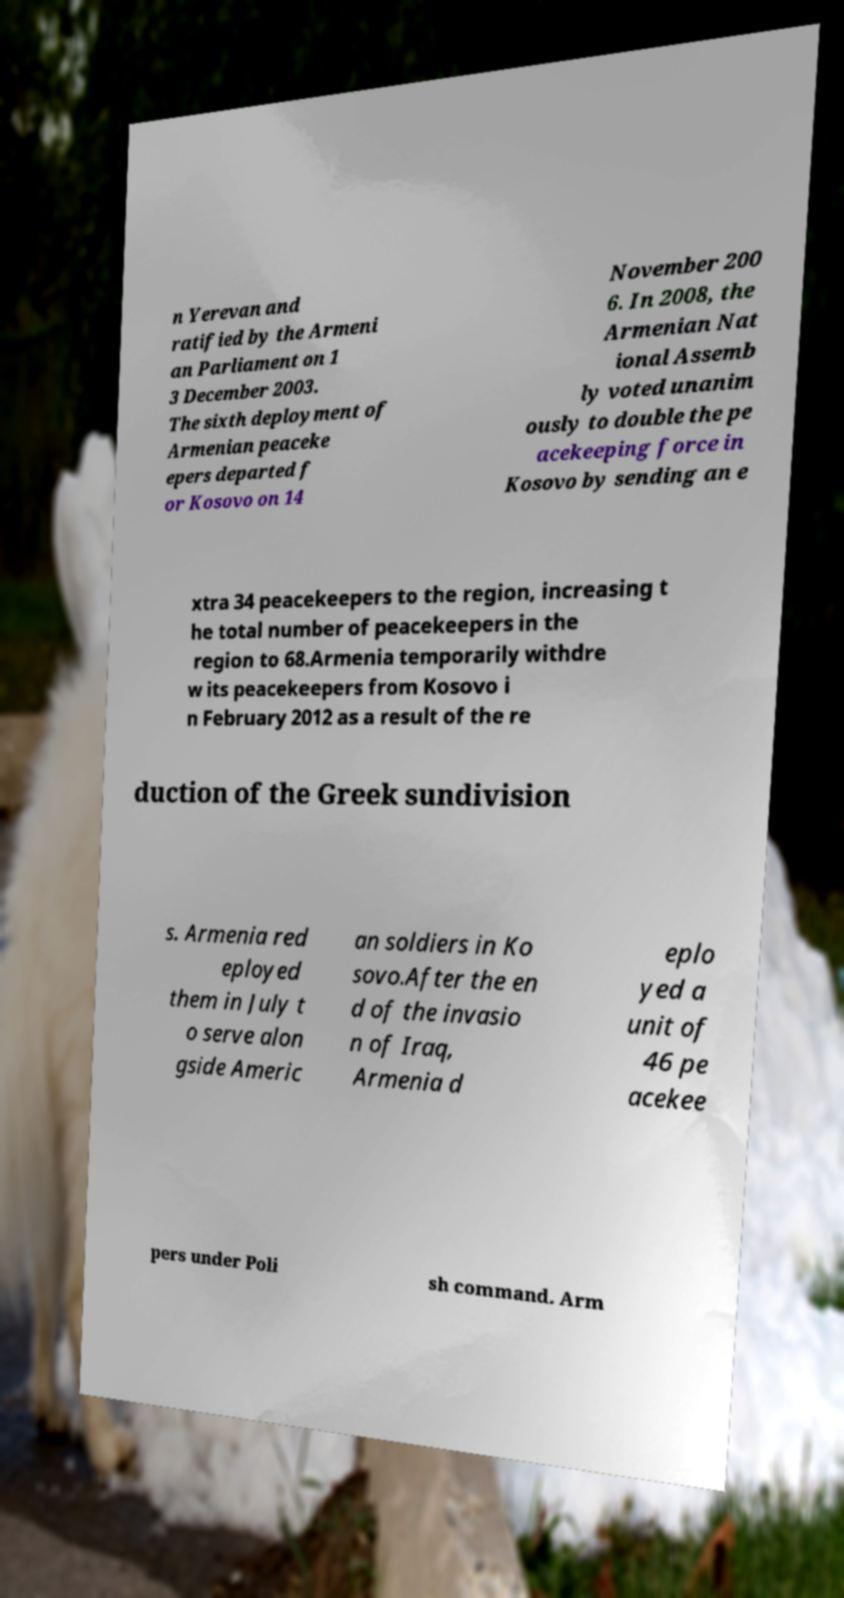For documentation purposes, I need the text within this image transcribed. Could you provide that? n Yerevan and ratified by the Armeni an Parliament on 1 3 December 2003. The sixth deployment of Armenian peaceke epers departed f or Kosovo on 14 November 200 6. In 2008, the Armenian Nat ional Assemb ly voted unanim ously to double the pe acekeeping force in Kosovo by sending an e xtra 34 peacekeepers to the region, increasing t he total number of peacekeepers in the region to 68.Armenia temporarily withdre w its peacekeepers from Kosovo i n February 2012 as a result of the re duction of the Greek sundivision s. Armenia red eployed them in July t o serve alon gside Americ an soldiers in Ko sovo.After the en d of the invasio n of Iraq, Armenia d eplo yed a unit of 46 pe acekee pers under Poli sh command. Arm 